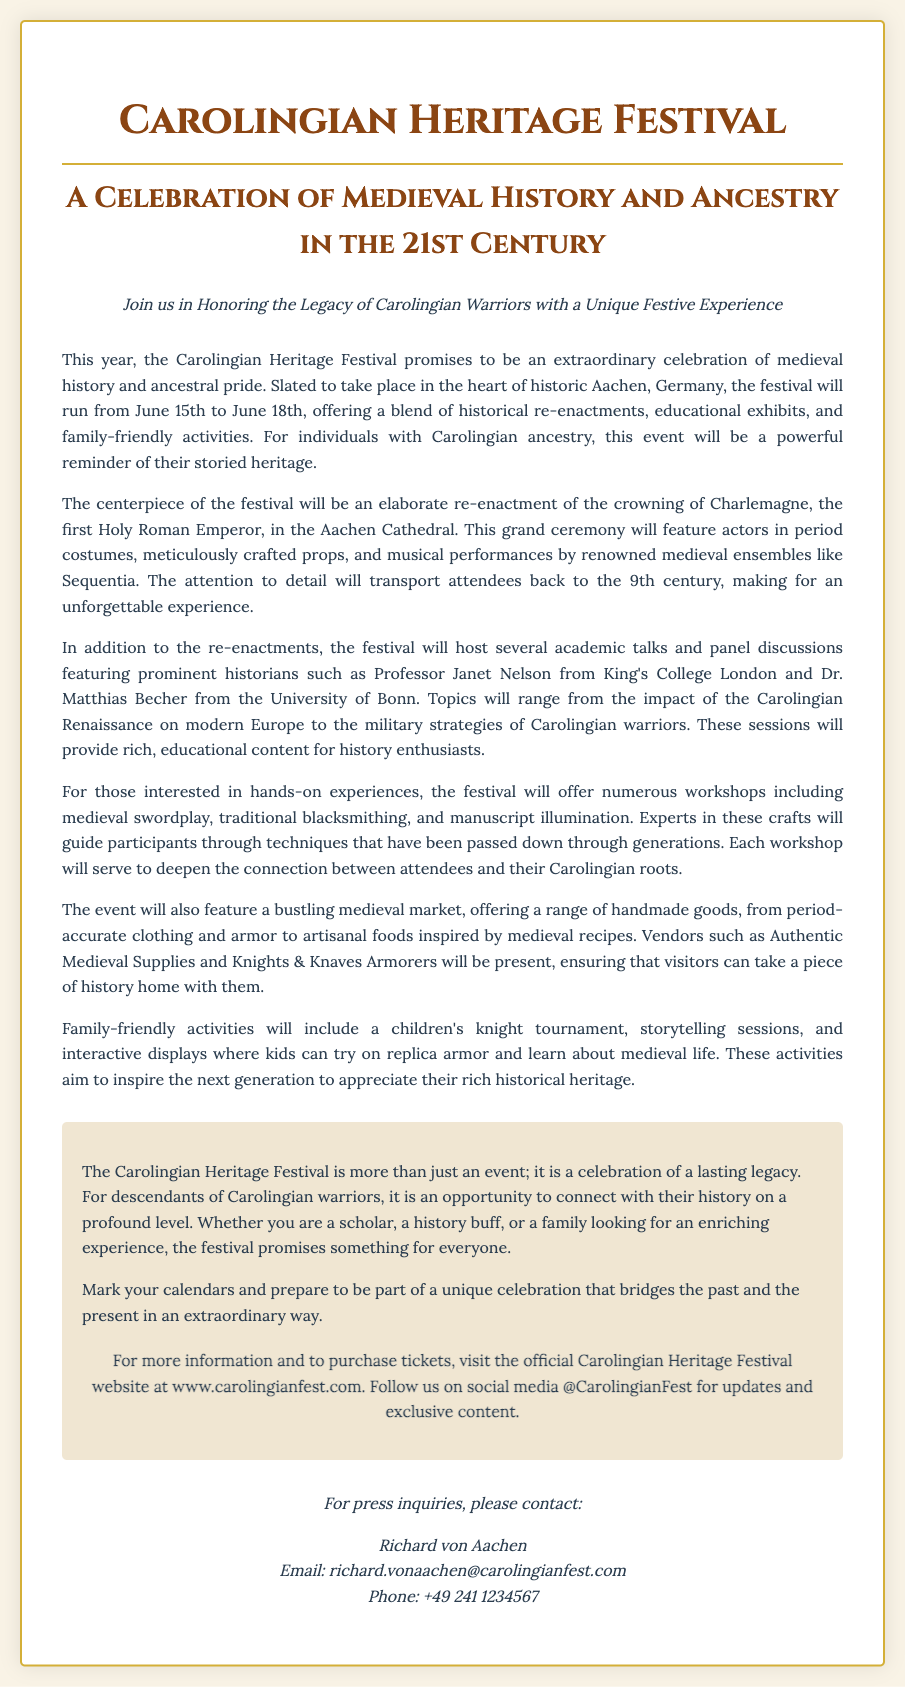What are the festival dates? The document states the festival will run from June 15th to June 18th.
Answer: June 15th to June 18th Who is the first Holy Roman Emperor? The document mentions Charlemagne as the first Holy Roman Emperor.
Answer: Charlemagne What type of workshops will be offered? The document lists workshops including medieval swordplay, traditional blacksmithing, and manuscript illumination.
Answer: Medieval swordplay, traditional blacksmithing, and manuscript illumination Which city is hosting the festival? The press release specifies that the festival will take place in the heart of historic Aachen, Germany.
Answer: Aachen, Germany Who will present academic talks? The document highlights historians such as Professor Janet Nelson and Dr. Matthias Becher.
Answer: Professor Janet Nelson and Dr. Matthias Becher What is the main feature of the festival? The centerpiece of the festival is described as an elaborate re-enactment of the crowning of Charlemagne.
Answer: Re-enactment of the crowning of Charlemagne What type of activities are included for children? The document mentions activities like a children's knight tournament and storytelling sessions for kids.
Answer: Children's knight tournament and storytelling sessions What can visitors find at the medieval market? The document states the market will offer handmade goods, including period-accurate clothing and armor.
Answer: Period-accurate clothing and armor 